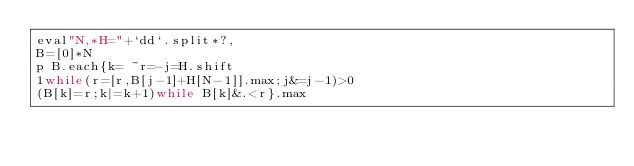<code> <loc_0><loc_0><loc_500><loc_500><_Ruby_>eval"N,*H="+`dd`.split*?,
B=[0]*N
p B.each{k= ~r=-j=H.shift
1while(r=[r,B[j-1]+H[N-1]].max;j&=j-1)>0
(B[k]=r;k|=k+1)while B[k]&.<r}.max</code> 